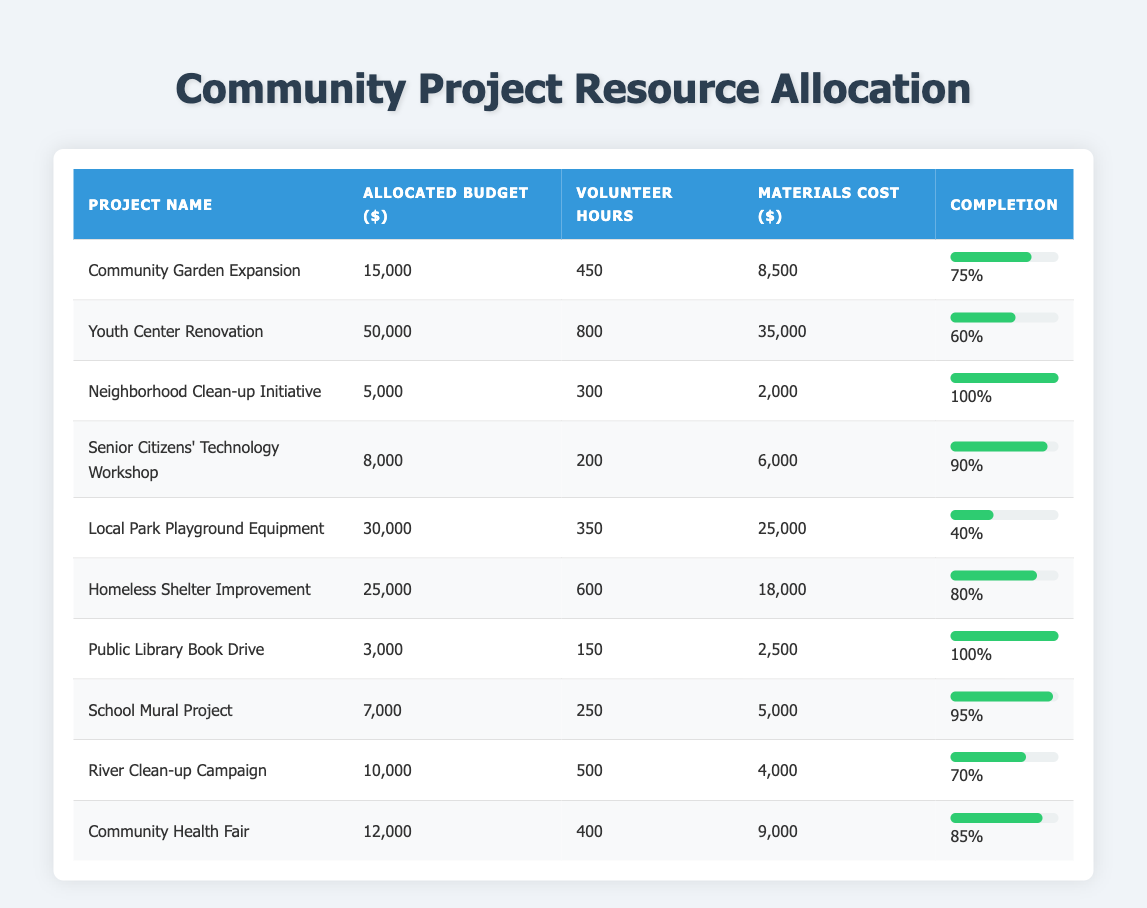What is the total allocated budget for all the projects? To find the total budget, we sum the allocated budget for each project: 15000 + 50000 + 5000 + 8000 + 30000 + 25000 + 3000 + 7000 + 10000 + 12000 = 109000.
Answer: 109000 Which project has the highest completion percentage? By reviewing the completion percentages for all projects, we see that the Neighborhood Clean-up Initiative and the Public Library Book Drive both have a completion percentage of 100%, which is the highest.
Answer: Neighborhood Clean-up Initiative, Public Library Book Drive Is the allocated budget for the Youth Center Renovation greater than the combined budget of the Community Garden Expansion and the Neighborhood Clean-up Initiative? The allocated budget for the Youth Center Renovation is 50000. The combined budget of the Community Garden Expansion (15000) and the Neighborhood Clean-up Initiative (5000) is 20000. Since 50000 is greater than 20000, the statement is true.
Answer: Yes What is the average completion percentage of all projects? To calculate the average, we sum all completion percentages: 75 + 60 + 100 + 90 + 40 + 80 + 100 + 95 + 70 + 85 = 795. We then divide by the number of projects (10): 795 / 10 = 79.5.
Answer: 79.5 How many volunteer hours were contributed to the Senior Citizens' Technology Workshop? Looking in the table under Volunteer Hours for the Senior Citizens' Technology Workshop, it shows 200 hours were contributed.
Answer: 200 Are there more volunteer hours in the Homeless Shelter Improvement project than in the Local Park Playground Equipment project? The Homeless Shelter Improvement project has 600 volunteer hours, while the Local Park Playground Equipment project has 350. Since 600 is greater than 350, the statement is true.
Answer: Yes Which project had the least allocated budget and what was it? The project with the least allocated budget is the Public Library Book Drive, with an allocated budget of 3000.
Answer: Public Library Book Drive, 3000 What is the total materials cost for all projects combined? Summing the materials cost for each project gives us: 8500 + 35000 + 2000 + 6000 + 25000 + 18000 + 2500 + 5000 + 4000 + 9000 = 115000.
Answer: 115000 Is the completion percentage of the Local Park Playground Equipment project above or below 50%? The completion percentage of the Local Park Playground Equipment project is 40%, which is below 50%.
Answer: Below 50% 